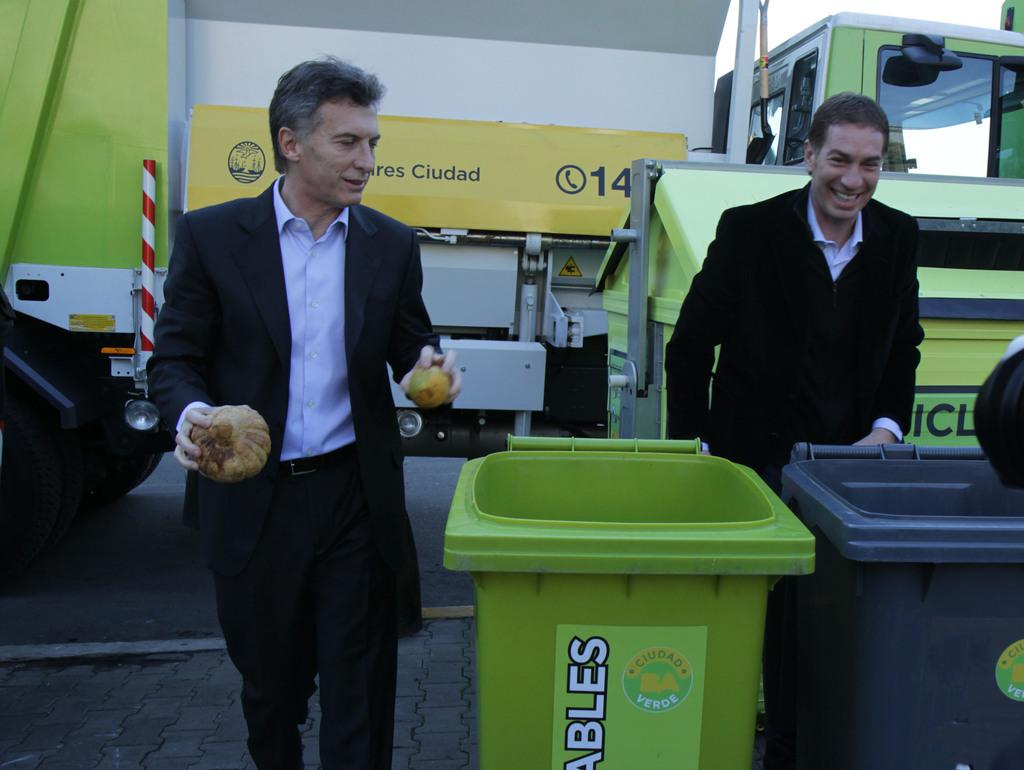<image>
Give a short and clear explanation of the subsequent image. Two men are seen in front of a yellow awning, which has the number 14 on it. 